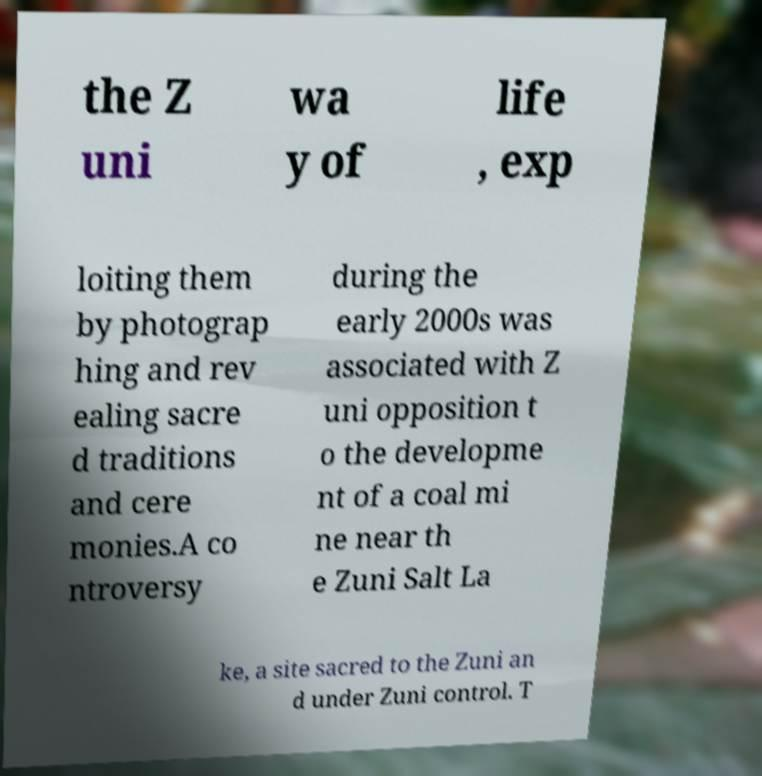Can you accurately transcribe the text from the provided image for me? the Z uni wa y of life , exp loiting them by photograp hing and rev ealing sacre d traditions and cere monies.A co ntroversy during the early 2000s was associated with Z uni opposition t o the developme nt of a coal mi ne near th e Zuni Salt La ke, a site sacred to the Zuni an d under Zuni control. T 